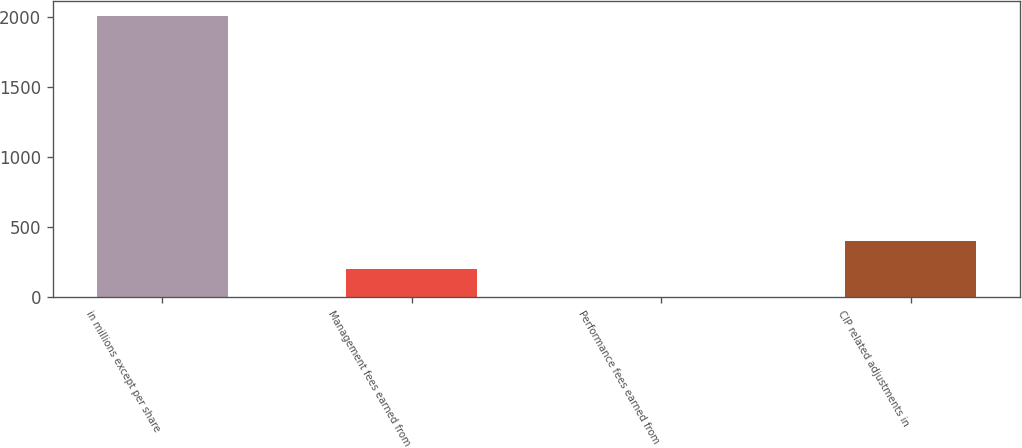<chart> <loc_0><loc_0><loc_500><loc_500><bar_chart><fcel>in millions except per share<fcel>Management fees earned from<fcel>Performance fees earned from<fcel>CIP related adjustments in<nl><fcel>2011<fcel>201.55<fcel>0.5<fcel>402.6<nl></chart> 